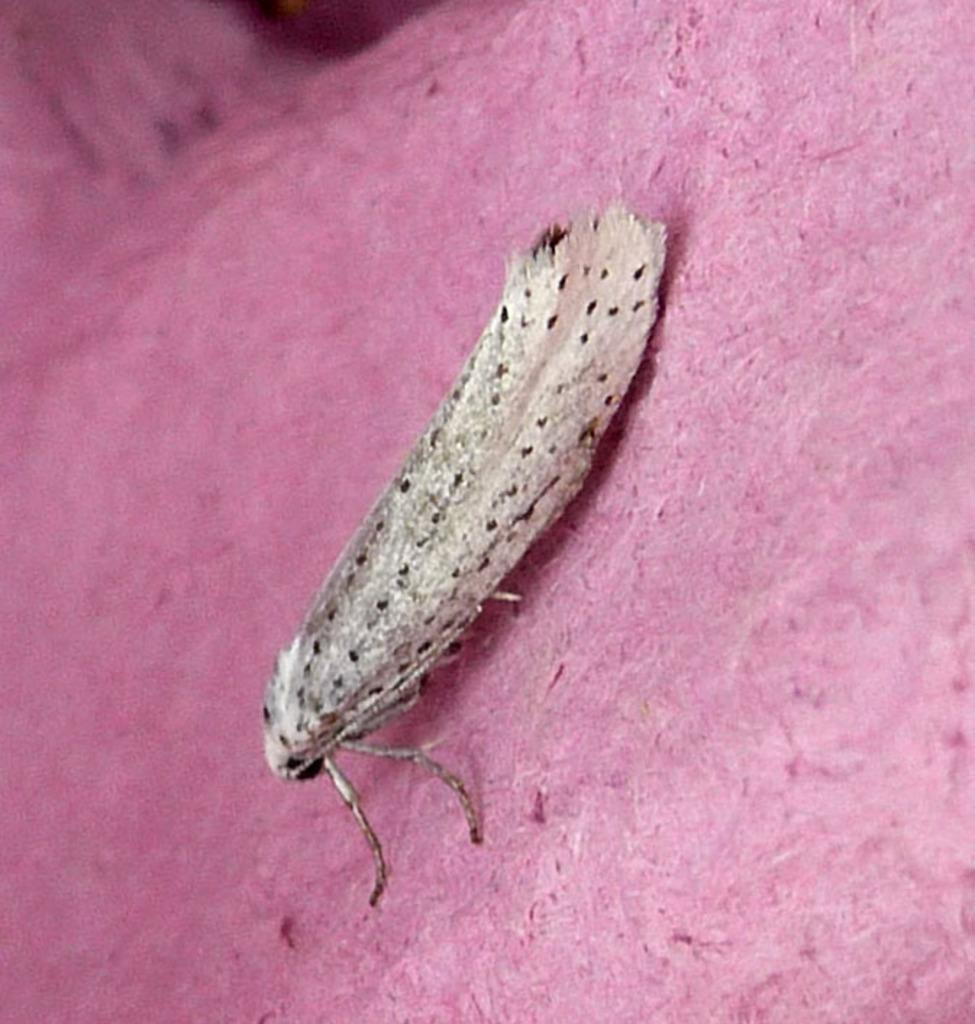What type of creature can be seen in the image? There is an insect in the image. What is the insect resting on or near? The insect is on a pink object. What type of scissors can be seen in the image? There are no scissors present in the image. What team is the insect a part of in the image? The image does not depict any teams or groupings, and the insect is not associated with any team. 